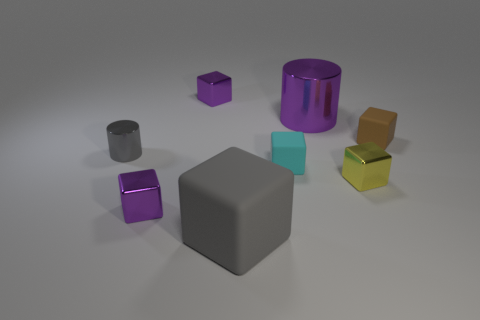Subtract 3 cubes. How many cubes are left? 3 Subtract all gray matte cubes. How many cubes are left? 5 Subtract all brown cubes. How many cubes are left? 5 Subtract all red blocks. Subtract all gray spheres. How many blocks are left? 6 Add 1 gray rubber cubes. How many objects exist? 9 Subtract all cylinders. How many objects are left? 6 Subtract all purple metallic objects. Subtract all purple metal things. How many objects are left? 2 Add 6 tiny gray metal cylinders. How many tiny gray metal cylinders are left? 7 Add 2 yellow metallic blocks. How many yellow metallic blocks exist? 3 Subtract 1 brown blocks. How many objects are left? 7 